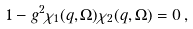<formula> <loc_0><loc_0><loc_500><loc_500>1 - g ^ { 2 } \chi _ { 1 } ( q , \Omega ) \chi _ { 2 } ( q , \Omega ) = 0 \, ,</formula> 